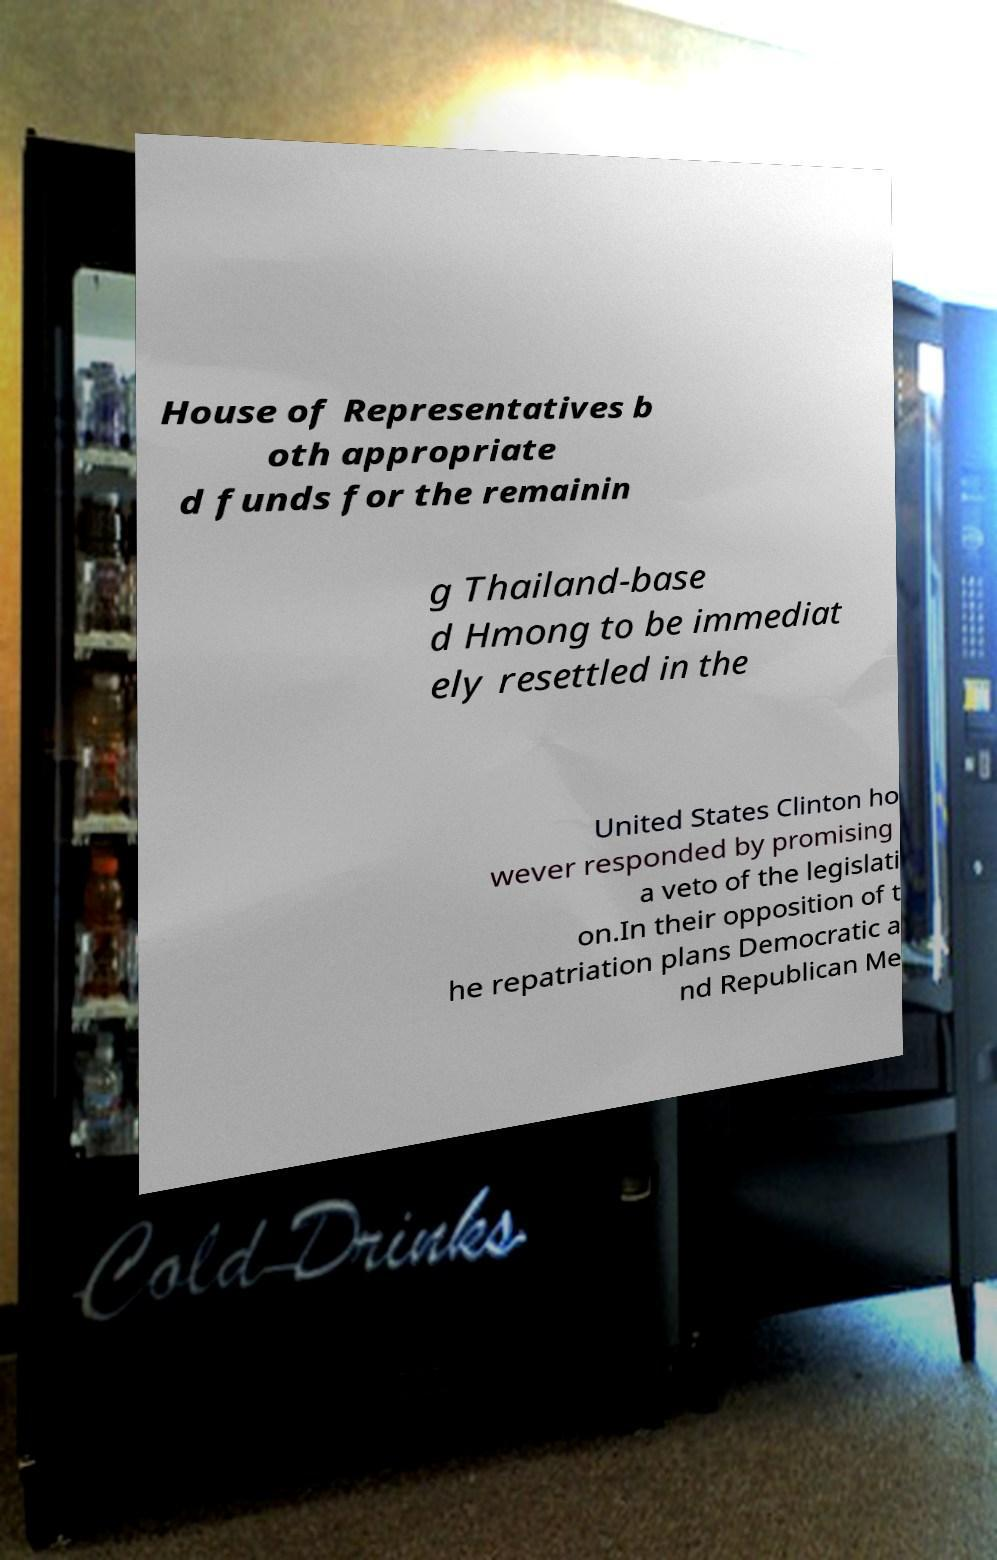Please identify and transcribe the text found in this image. House of Representatives b oth appropriate d funds for the remainin g Thailand-base d Hmong to be immediat ely resettled in the United States Clinton ho wever responded by promising a veto of the legislati on.In their opposition of t he repatriation plans Democratic a nd Republican Me 